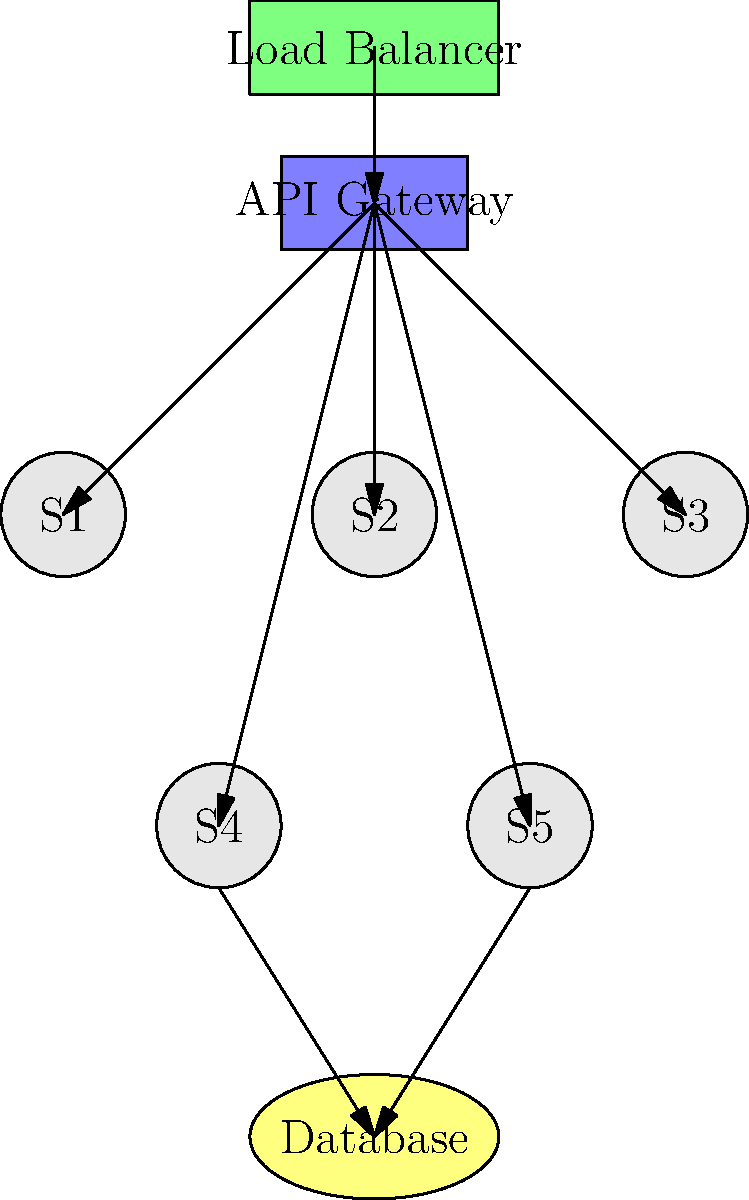In the given microservices architecture diagram, which component serves as the entry point for all client requests and routes them to the appropriate microservices? To determine the entry point for client requests in this microservices architecture, let's analyze the components and their relationships:

1. The diagram shows several components: Load Balancer, API Gateway, Microservices (S1, S2, S3, S4, S5), and a Database.

2. The Load Balancer is at the top of the diagram, connected to the API Gateway.

3. The API Gateway is connected to all the microservices (S1, S2, S3, S4, S5).

4. Some microservices (S4 and S5) are connected to the Database.

5. The flow of arrows indicates that requests come from the Load Balancer to the API Gateway, and then from the API Gateway to the individual microservices.

6. In a typical microservices architecture, the API Gateway serves as the single entry point for all client requests. It acts as a reverse proxy, routing requests to the appropriate microservices based on the request type and URL.

7. The Load Balancer, while important for distributing traffic, is not responsible for routing requests to specific microservices. Its primary function is to distribute incoming network traffic across multiple servers to ensure no single server bears too much load.

Given this analysis, we can conclude that the API Gateway is the component that serves as the entry point for all client requests and routes them to the appropriate microservices.
Answer: API Gateway 